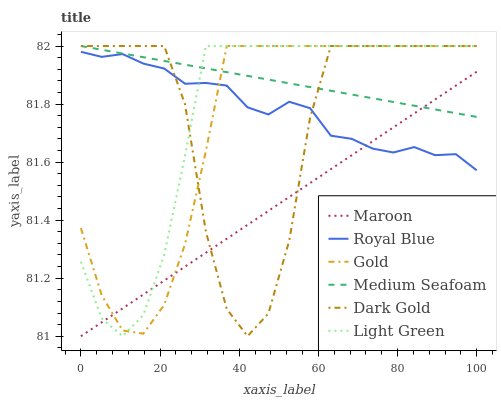Does Maroon have the minimum area under the curve?
Answer yes or no. Yes. Does Medium Seafoam have the maximum area under the curve?
Answer yes or no. Yes. Does Dark Gold have the minimum area under the curve?
Answer yes or no. No. Does Dark Gold have the maximum area under the curve?
Answer yes or no. No. Is Medium Seafoam the smoothest?
Answer yes or no. Yes. Is Dark Gold the roughest?
Answer yes or no. Yes. Is Maroon the smoothest?
Answer yes or no. No. Is Maroon the roughest?
Answer yes or no. No. Does Dark Gold have the lowest value?
Answer yes or no. No. Does Medium Seafoam have the highest value?
Answer yes or no. Yes. Does Maroon have the highest value?
Answer yes or no. No. Is Royal Blue less than Medium Seafoam?
Answer yes or no. Yes. Is Medium Seafoam greater than Royal Blue?
Answer yes or no. Yes. Does Maroon intersect Dark Gold?
Answer yes or no. Yes. Is Maroon less than Dark Gold?
Answer yes or no. No. Is Maroon greater than Dark Gold?
Answer yes or no. No. Does Royal Blue intersect Medium Seafoam?
Answer yes or no. No. 